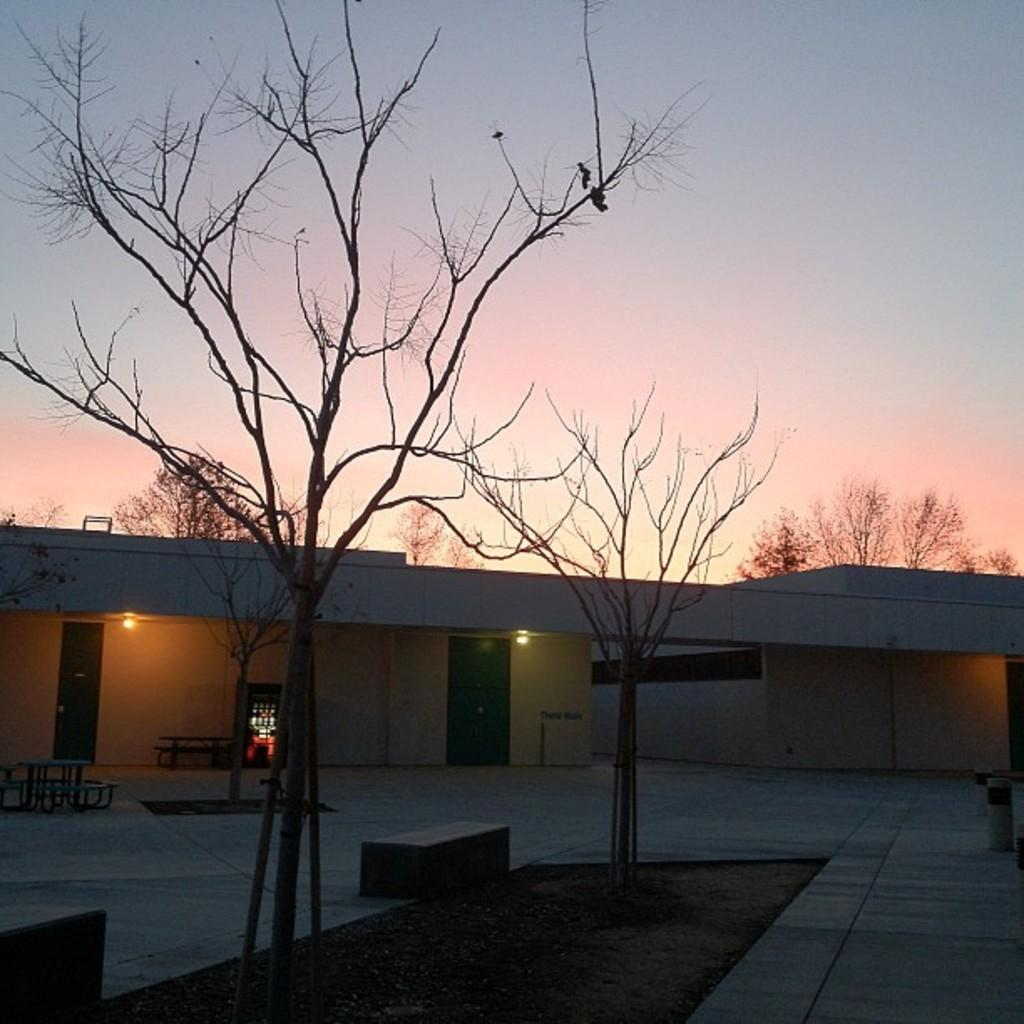What type of natural elements can be seen in the image? There are trees in the image. What type of man-made structure is present in the image? There is a building in the image. What can be used for illumination in the image? There are lights in the image. What type of seating is available in the image? There are benches in the image. What is visible in the background of the image? The sky is visible in the image. Can you tell me how many owls are sitting on the benches in the image? There are no owls present in the image; it features trees, a building, lights, benches, and the sky. What type of property is being sold in the image? There is no property being sold in the image; it is a scene with trees, a building, lights, benches, and the sky. 